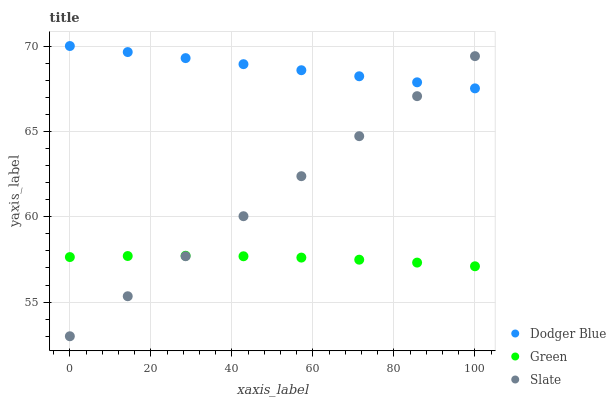Does Green have the minimum area under the curve?
Answer yes or no. Yes. Does Dodger Blue have the maximum area under the curve?
Answer yes or no. Yes. Does Slate have the minimum area under the curve?
Answer yes or no. No. Does Slate have the maximum area under the curve?
Answer yes or no. No. Is Dodger Blue the smoothest?
Answer yes or no. Yes. Is Green the roughest?
Answer yes or no. Yes. Is Slate the smoothest?
Answer yes or no. No. Is Slate the roughest?
Answer yes or no. No. Does Slate have the lowest value?
Answer yes or no. Yes. Does Dodger Blue have the lowest value?
Answer yes or no. No. Does Dodger Blue have the highest value?
Answer yes or no. Yes. Does Slate have the highest value?
Answer yes or no. No. Is Green less than Dodger Blue?
Answer yes or no. Yes. Is Dodger Blue greater than Green?
Answer yes or no. Yes. Does Slate intersect Green?
Answer yes or no. Yes. Is Slate less than Green?
Answer yes or no. No. Is Slate greater than Green?
Answer yes or no. No. Does Green intersect Dodger Blue?
Answer yes or no. No. 